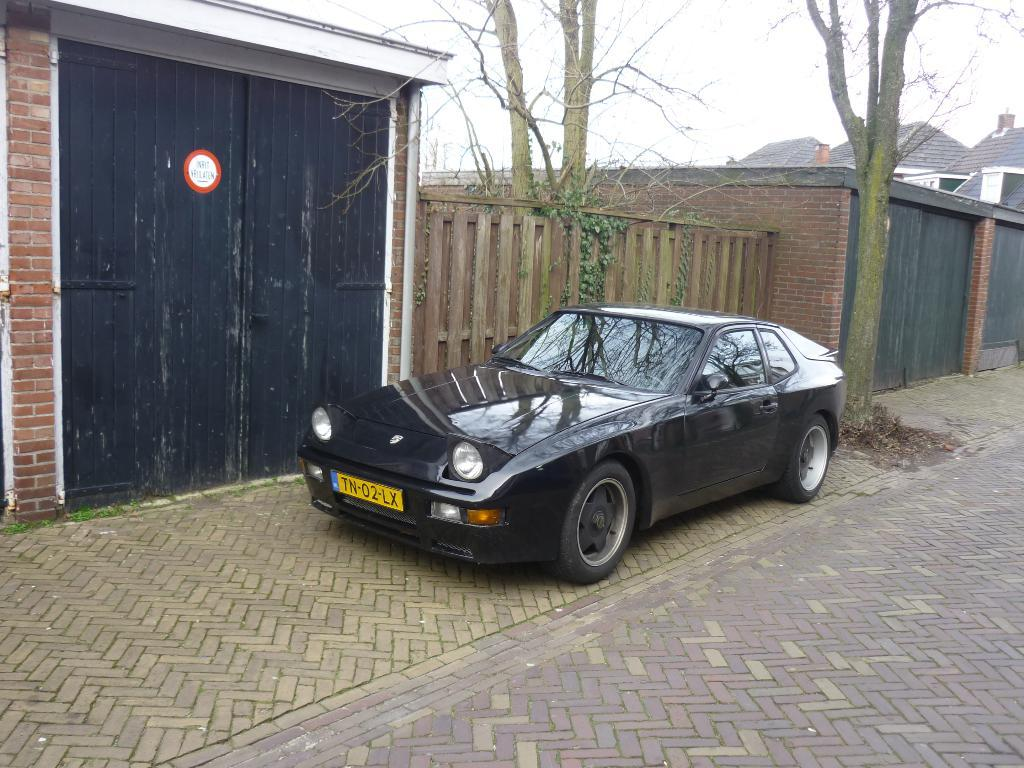What type of object is the main subject of the image? There is a vehicle in the image. What color is the vehicle? The vehicle is black. What can be seen in the background of the image? There is a door, houses, and dried trees in the background of the image. What is the color of the sky in the image? The sky is white in color. What type of leaf can be seen falling from the sky in the image? There are no leaves visible in the image, and the sky is white, not blue or green, where leaves would typically be found. 